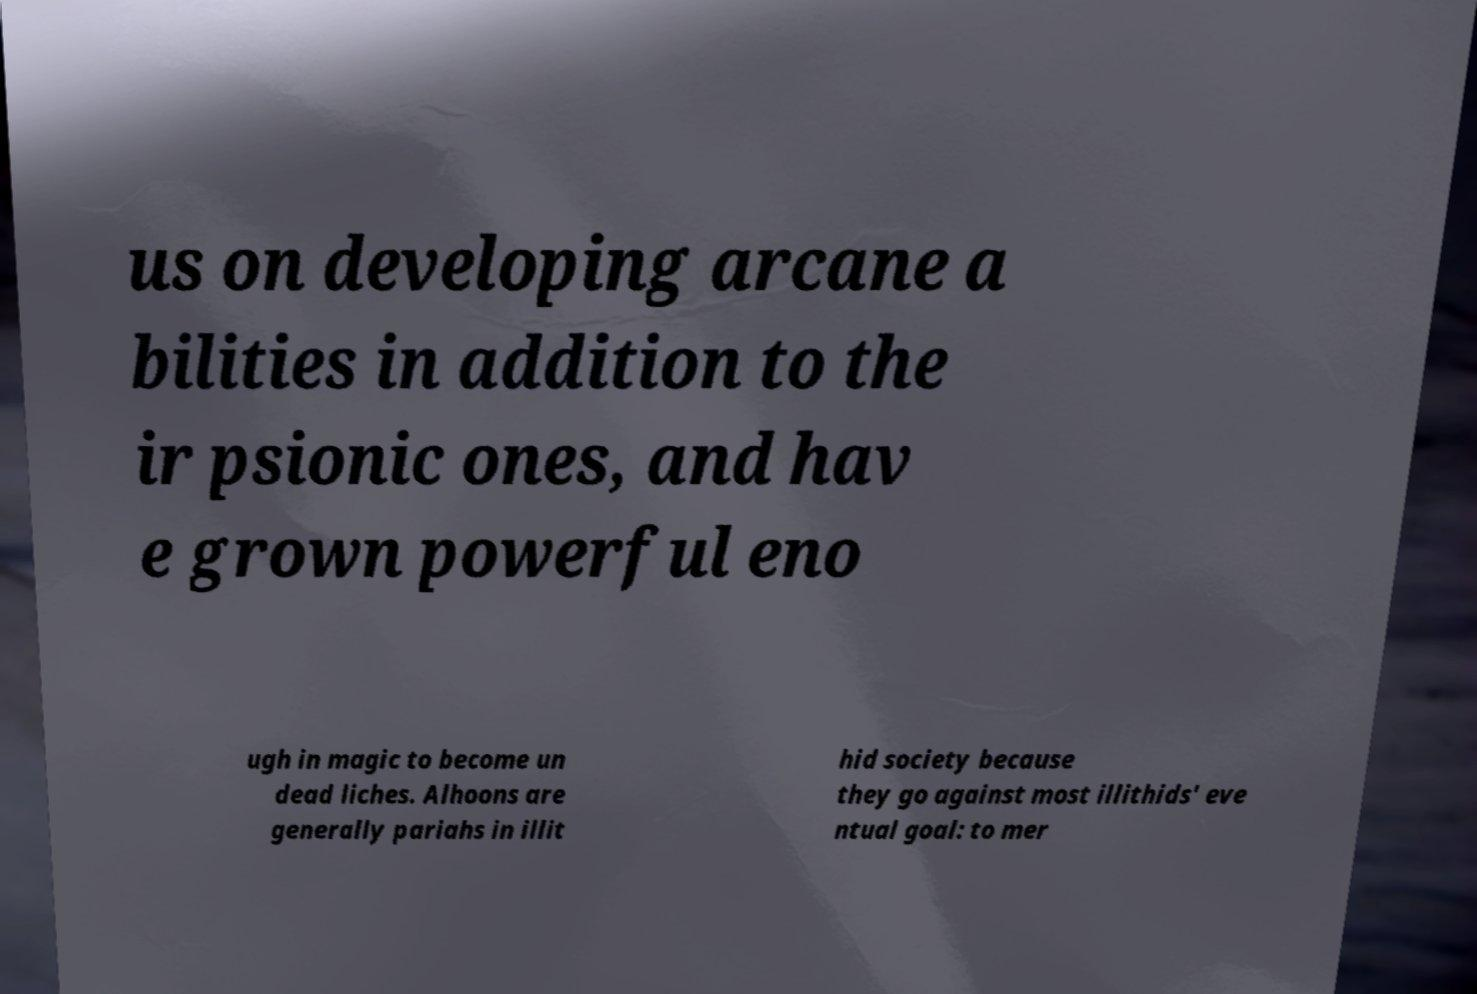For documentation purposes, I need the text within this image transcribed. Could you provide that? us on developing arcane a bilities in addition to the ir psionic ones, and hav e grown powerful eno ugh in magic to become un dead liches. Alhoons are generally pariahs in illit hid society because they go against most illithids' eve ntual goal: to mer 